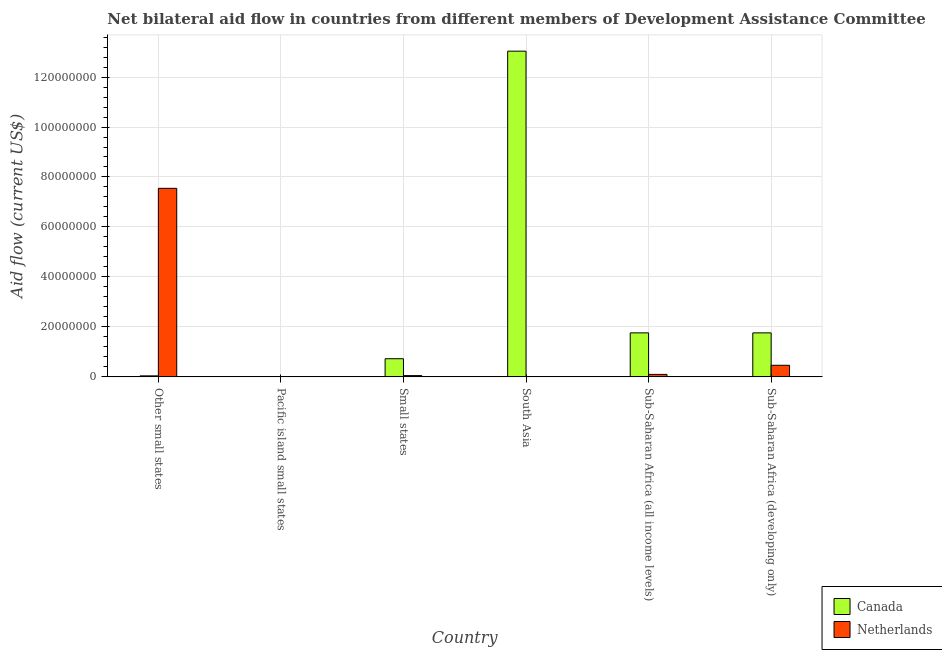How many different coloured bars are there?
Provide a short and direct response. 2. Are the number of bars per tick equal to the number of legend labels?
Ensure brevity in your answer.  No. What is the label of the 6th group of bars from the left?
Make the answer very short. Sub-Saharan Africa (developing only). What is the amount of aid given by canada in South Asia?
Offer a very short reply. 1.30e+08. Across all countries, what is the maximum amount of aid given by canada?
Your answer should be compact. 1.30e+08. In which country was the amount of aid given by netherlands maximum?
Make the answer very short. Other small states. What is the total amount of aid given by canada in the graph?
Make the answer very short. 1.73e+08. What is the difference between the amount of aid given by netherlands in Sub-Saharan Africa (developing only) and the amount of aid given by canada in Other small states?
Give a very brief answer. 4.23e+06. What is the average amount of aid given by netherlands per country?
Your response must be concise. 1.36e+07. What is the difference between the amount of aid given by canada and amount of aid given by netherlands in Other small states?
Ensure brevity in your answer.  -7.50e+07. What is the ratio of the amount of aid given by netherlands in Other small states to that in Small states?
Your response must be concise. 147.96. Is the amount of aid given by netherlands in Small states less than that in South Asia?
Your answer should be very brief. No. Is the difference between the amount of aid given by netherlands in Other small states and Small states greater than the difference between the amount of aid given by canada in Other small states and Small states?
Ensure brevity in your answer.  Yes. What is the difference between the highest and the second highest amount of aid given by netherlands?
Your answer should be very brief. 7.08e+07. What is the difference between the highest and the lowest amount of aid given by netherlands?
Make the answer very short. 7.55e+07. In how many countries, is the amount of aid given by netherlands greater than the average amount of aid given by netherlands taken over all countries?
Provide a short and direct response. 1. How many bars are there?
Keep it short and to the point. 11. Are all the bars in the graph horizontal?
Your answer should be compact. No. How many countries are there in the graph?
Keep it short and to the point. 6. What is the difference between two consecutive major ticks on the Y-axis?
Offer a very short reply. 2.00e+07. Does the graph contain grids?
Provide a short and direct response. Yes. Where does the legend appear in the graph?
Your answer should be compact. Bottom right. What is the title of the graph?
Your answer should be very brief. Net bilateral aid flow in countries from different members of Development Assistance Committee. Does "Number of arrivals" appear as one of the legend labels in the graph?
Provide a short and direct response. No. What is the label or title of the Y-axis?
Your response must be concise. Aid flow (current US$). What is the Aid flow (current US$) in Netherlands in Other small states?
Give a very brief answer. 7.55e+07. What is the Aid flow (current US$) of Netherlands in Pacific island small states?
Keep it short and to the point. 0. What is the Aid flow (current US$) in Canada in Small states?
Provide a succinct answer. 7.26e+06. What is the Aid flow (current US$) in Netherlands in Small states?
Ensure brevity in your answer.  5.10e+05. What is the Aid flow (current US$) of Canada in South Asia?
Offer a very short reply. 1.30e+08. What is the Aid flow (current US$) in Canada in Sub-Saharan Africa (all income levels)?
Your answer should be compact. 1.76e+07. What is the Aid flow (current US$) of Netherlands in Sub-Saharan Africa (all income levels)?
Your answer should be very brief. 9.90e+05. What is the Aid flow (current US$) in Canada in Sub-Saharan Africa (developing only)?
Ensure brevity in your answer.  1.76e+07. What is the Aid flow (current US$) of Netherlands in Sub-Saharan Africa (developing only)?
Offer a very short reply. 4.64e+06. Across all countries, what is the maximum Aid flow (current US$) in Canada?
Provide a succinct answer. 1.30e+08. Across all countries, what is the maximum Aid flow (current US$) of Netherlands?
Give a very brief answer. 7.55e+07. What is the total Aid flow (current US$) in Canada in the graph?
Keep it short and to the point. 1.73e+08. What is the total Aid flow (current US$) in Netherlands in the graph?
Provide a succinct answer. 8.17e+07. What is the difference between the Aid flow (current US$) in Canada in Other small states and that in Small states?
Your answer should be very brief. -6.85e+06. What is the difference between the Aid flow (current US$) in Netherlands in Other small states and that in Small states?
Keep it short and to the point. 7.50e+07. What is the difference between the Aid flow (current US$) in Canada in Other small states and that in South Asia?
Give a very brief answer. -1.30e+08. What is the difference between the Aid flow (current US$) of Netherlands in Other small states and that in South Asia?
Give a very brief answer. 7.53e+07. What is the difference between the Aid flow (current US$) of Canada in Other small states and that in Sub-Saharan Africa (all income levels)?
Your response must be concise. -1.72e+07. What is the difference between the Aid flow (current US$) in Netherlands in Other small states and that in Sub-Saharan Africa (all income levels)?
Keep it short and to the point. 7.45e+07. What is the difference between the Aid flow (current US$) in Canada in Other small states and that in Sub-Saharan Africa (developing only)?
Keep it short and to the point. -1.72e+07. What is the difference between the Aid flow (current US$) in Netherlands in Other small states and that in Sub-Saharan Africa (developing only)?
Make the answer very short. 7.08e+07. What is the difference between the Aid flow (current US$) of Canada in Pacific island small states and that in Small states?
Offer a very short reply. -7.24e+06. What is the difference between the Aid flow (current US$) in Canada in Pacific island small states and that in South Asia?
Give a very brief answer. -1.30e+08. What is the difference between the Aid flow (current US$) in Canada in Pacific island small states and that in Sub-Saharan Africa (all income levels)?
Ensure brevity in your answer.  -1.76e+07. What is the difference between the Aid flow (current US$) of Canada in Pacific island small states and that in Sub-Saharan Africa (developing only)?
Keep it short and to the point. -1.76e+07. What is the difference between the Aid flow (current US$) of Canada in Small states and that in South Asia?
Offer a terse response. -1.23e+08. What is the difference between the Aid flow (current US$) of Netherlands in Small states and that in South Asia?
Make the answer very short. 3.80e+05. What is the difference between the Aid flow (current US$) in Canada in Small states and that in Sub-Saharan Africa (all income levels)?
Make the answer very short. -1.04e+07. What is the difference between the Aid flow (current US$) of Netherlands in Small states and that in Sub-Saharan Africa (all income levels)?
Your response must be concise. -4.80e+05. What is the difference between the Aid flow (current US$) in Canada in Small states and that in Sub-Saharan Africa (developing only)?
Provide a succinct answer. -1.04e+07. What is the difference between the Aid flow (current US$) in Netherlands in Small states and that in Sub-Saharan Africa (developing only)?
Your response must be concise. -4.13e+06. What is the difference between the Aid flow (current US$) in Canada in South Asia and that in Sub-Saharan Africa (all income levels)?
Give a very brief answer. 1.13e+08. What is the difference between the Aid flow (current US$) of Netherlands in South Asia and that in Sub-Saharan Africa (all income levels)?
Provide a succinct answer. -8.60e+05. What is the difference between the Aid flow (current US$) of Canada in South Asia and that in Sub-Saharan Africa (developing only)?
Your response must be concise. 1.13e+08. What is the difference between the Aid flow (current US$) of Netherlands in South Asia and that in Sub-Saharan Africa (developing only)?
Offer a very short reply. -4.51e+06. What is the difference between the Aid flow (current US$) in Netherlands in Sub-Saharan Africa (all income levels) and that in Sub-Saharan Africa (developing only)?
Offer a very short reply. -3.65e+06. What is the difference between the Aid flow (current US$) of Canada in Other small states and the Aid flow (current US$) of Netherlands in Small states?
Your answer should be very brief. -1.00e+05. What is the difference between the Aid flow (current US$) in Canada in Other small states and the Aid flow (current US$) in Netherlands in South Asia?
Provide a succinct answer. 2.80e+05. What is the difference between the Aid flow (current US$) of Canada in Other small states and the Aid flow (current US$) of Netherlands in Sub-Saharan Africa (all income levels)?
Offer a very short reply. -5.80e+05. What is the difference between the Aid flow (current US$) of Canada in Other small states and the Aid flow (current US$) of Netherlands in Sub-Saharan Africa (developing only)?
Give a very brief answer. -4.23e+06. What is the difference between the Aid flow (current US$) in Canada in Pacific island small states and the Aid flow (current US$) in Netherlands in Small states?
Offer a very short reply. -4.90e+05. What is the difference between the Aid flow (current US$) of Canada in Pacific island small states and the Aid flow (current US$) of Netherlands in South Asia?
Your response must be concise. -1.10e+05. What is the difference between the Aid flow (current US$) in Canada in Pacific island small states and the Aid flow (current US$) in Netherlands in Sub-Saharan Africa (all income levels)?
Provide a short and direct response. -9.70e+05. What is the difference between the Aid flow (current US$) in Canada in Pacific island small states and the Aid flow (current US$) in Netherlands in Sub-Saharan Africa (developing only)?
Ensure brevity in your answer.  -4.62e+06. What is the difference between the Aid flow (current US$) in Canada in Small states and the Aid flow (current US$) in Netherlands in South Asia?
Your response must be concise. 7.13e+06. What is the difference between the Aid flow (current US$) of Canada in Small states and the Aid flow (current US$) of Netherlands in Sub-Saharan Africa (all income levels)?
Give a very brief answer. 6.27e+06. What is the difference between the Aid flow (current US$) in Canada in Small states and the Aid flow (current US$) in Netherlands in Sub-Saharan Africa (developing only)?
Give a very brief answer. 2.62e+06. What is the difference between the Aid flow (current US$) of Canada in South Asia and the Aid flow (current US$) of Netherlands in Sub-Saharan Africa (all income levels)?
Offer a terse response. 1.29e+08. What is the difference between the Aid flow (current US$) in Canada in South Asia and the Aid flow (current US$) in Netherlands in Sub-Saharan Africa (developing only)?
Offer a very short reply. 1.26e+08. What is the difference between the Aid flow (current US$) of Canada in Sub-Saharan Africa (all income levels) and the Aid flow (current US$) of Netherlands in Sub-Saharan Africa (developing only)?
Give a very brief answer. 1.30e+07. What is the average Aid flow (current US$) in Canada per country?
Provide a succinct answer. 2.89e+07. What is the average Aid flow (current US$) in Netherlands per country?
Your answer should be very brief. 1.36e+07. What is the difference between the Aid flow (current US$) of Canada and Aid flow (current US$) of Netherlands in Other small states?
Give a very brief answer. -7.50e+07. What is the difference between the Aid flow (current US$) of Canada and Aid flow (current US$) of Netherlands in Small states?
Make the answer very short. 6.75e+06. What is the difference between the Aid flow (current US$) of Canada and Aid flow (current US$) of Netherlands in South Asia?
Ensure brevity in your answer.  1.30e+08. What is the difference between the Aid flow (current US$) in Canada and Aid flow (current US$) in Netherlands in Sub-Saharan Africa (all income levels)?
Keep it short and to the point. 1.66e+07. What is the difference between the Aid flow (current US$) in Canada and Aid flow (current US$) in Netherlands in Sub-Saharan Africa (developing only)?
Give a very brief answer. 1.30e+07. What is the ratio of the Aid flow (current US$) of Canada in Other small states to that in Small states?
Give a very brief answer. 0.06. What is the ratio of the Aid flow (current US$) of Netherlands in Other small states to that in Small states?
Make the answer very short. 147.96. What is the ratio of the Aid flow (current US$) of Canada in Other small states to that in South Asia?
Your response must be concise. 0. What is the ratio of the Aid flow (current US$) in Netherlands in Other small states to that in South Asia?
Your response must be concise. 580.46. What is the ratio of the Aid flow (current US$) in Canada in Other small states to that in Sub-Saharan Africa (all income levels)?
Provide a succinct answer. 0.02. What is the ratio of the Aid flow (current US$) of Netherlands in Other small states to that in Sub-Saharan Africa (all income levels)?
Provide a short and direct response. 76.22. What is the ratio of the Aid flow (current US$) of Canada in Other small states to that in Sub-Saharan Africa (developing only)?
Provide a succinct answer. 0.02. What is the ratio of the Aid flow (current US$) in Netherlands in Other small states to that in Sub-Saharan Africa (developing only)?
Provide a short and direct response. 16.26. What is the ratio of the Aid flow (current US$) in Canada in Pacific island small states to that in Small states?
Offer a very short reply. 0. What is the ratio of the Aid flow (current US$) in Canada in Pacific island small states to that in South Asia?
Your response must be concise. 0. What is the ratio of the Aid flow (current US$) of Canada in Pacific island small states to that in Sub-Saharan Africa (all income levels)?
Provide a succinct answer. 0. What is the ratio of the Aid flow (current US$) of Canada in Pacific island small states to that in Sub-Saharan Africa (developing only)?
Offer a terse response. 0. What is the ratio of the Aid flow (current US$) of Canada in Small states to that in South Asia?
Make the answer very short. 0.06. What is the ratio of the Aid flow (current US$) of Netherlands in Small states to that in South Asia?
Your answer should be very brief. 3.92. What is the ratio of the Aid flow (current US$) of Canada in Small states to that in Sub-Saharan Africa (all income levels)?
Your answer should be very brief. 0.41. What is the ratio of the Aid flow (current US$) in Netherlands in Small states to that in Sub-Saharan Africa (all income levels)?
Provide a succinct answer. 0.52. What is the ratio of the Aid flow (current US$) in Canada in Small states to that in Sub-Saharan Africa (developing only)?
Provide a succinct answer. 0.41. What is the ratio of the Aid flow (current US$) of Netherlands in Small states to that in Sub-Saharan Africa (developing only)?
Your answer should be compact. 0.11. What is the ratio of the Aid flow (current US$) of Canada in South Asia to that in Sub-Saharan Africa (all income levels)?
Your answer should be compact. 7.4. What is the ratio of the Aid flow (current US$) in Netherlands in South Asia to that in Sub-Saharan Africa (all income levels)?
Ensure brevity in your answer.  0.13. What is the ratio of the Aid flow (current US$) of Canada in South Asia to that in Sub-Saharan Africa (developing only)?
Offer a very short reply. 7.4. What is the ratio of the Aid flow (current US$) of Netherlands in South Asia to that in Sub-Saharan Africa (developing only)?
Your answer should be very brief. 0.03. What is the ratio of the Aid flow (current US$) in Netherlands in Sub-Saharan Africa (all income levels) to that in Sub-Saharan Africa (developing only)?
Give a very brief answer. 0.21. What is the difference between the highest and the second highest Aid flow (current US$) in Canada?
Your answer should be very brief. 1.13e+08. What is the difference between the highest and the second highest Aid flow (current US$) of Netherlands?
Give a very brief answer. 7.08e+07. What is the difference between the highest and the lowest Aid flow (current US$) in Canada?
Offer a very short reply. 1.30e+08. What is the difference between the highest and the lowest Aid flow (current US$) in Netherlands?
Keep it short and to the point. 7.55e+07. 